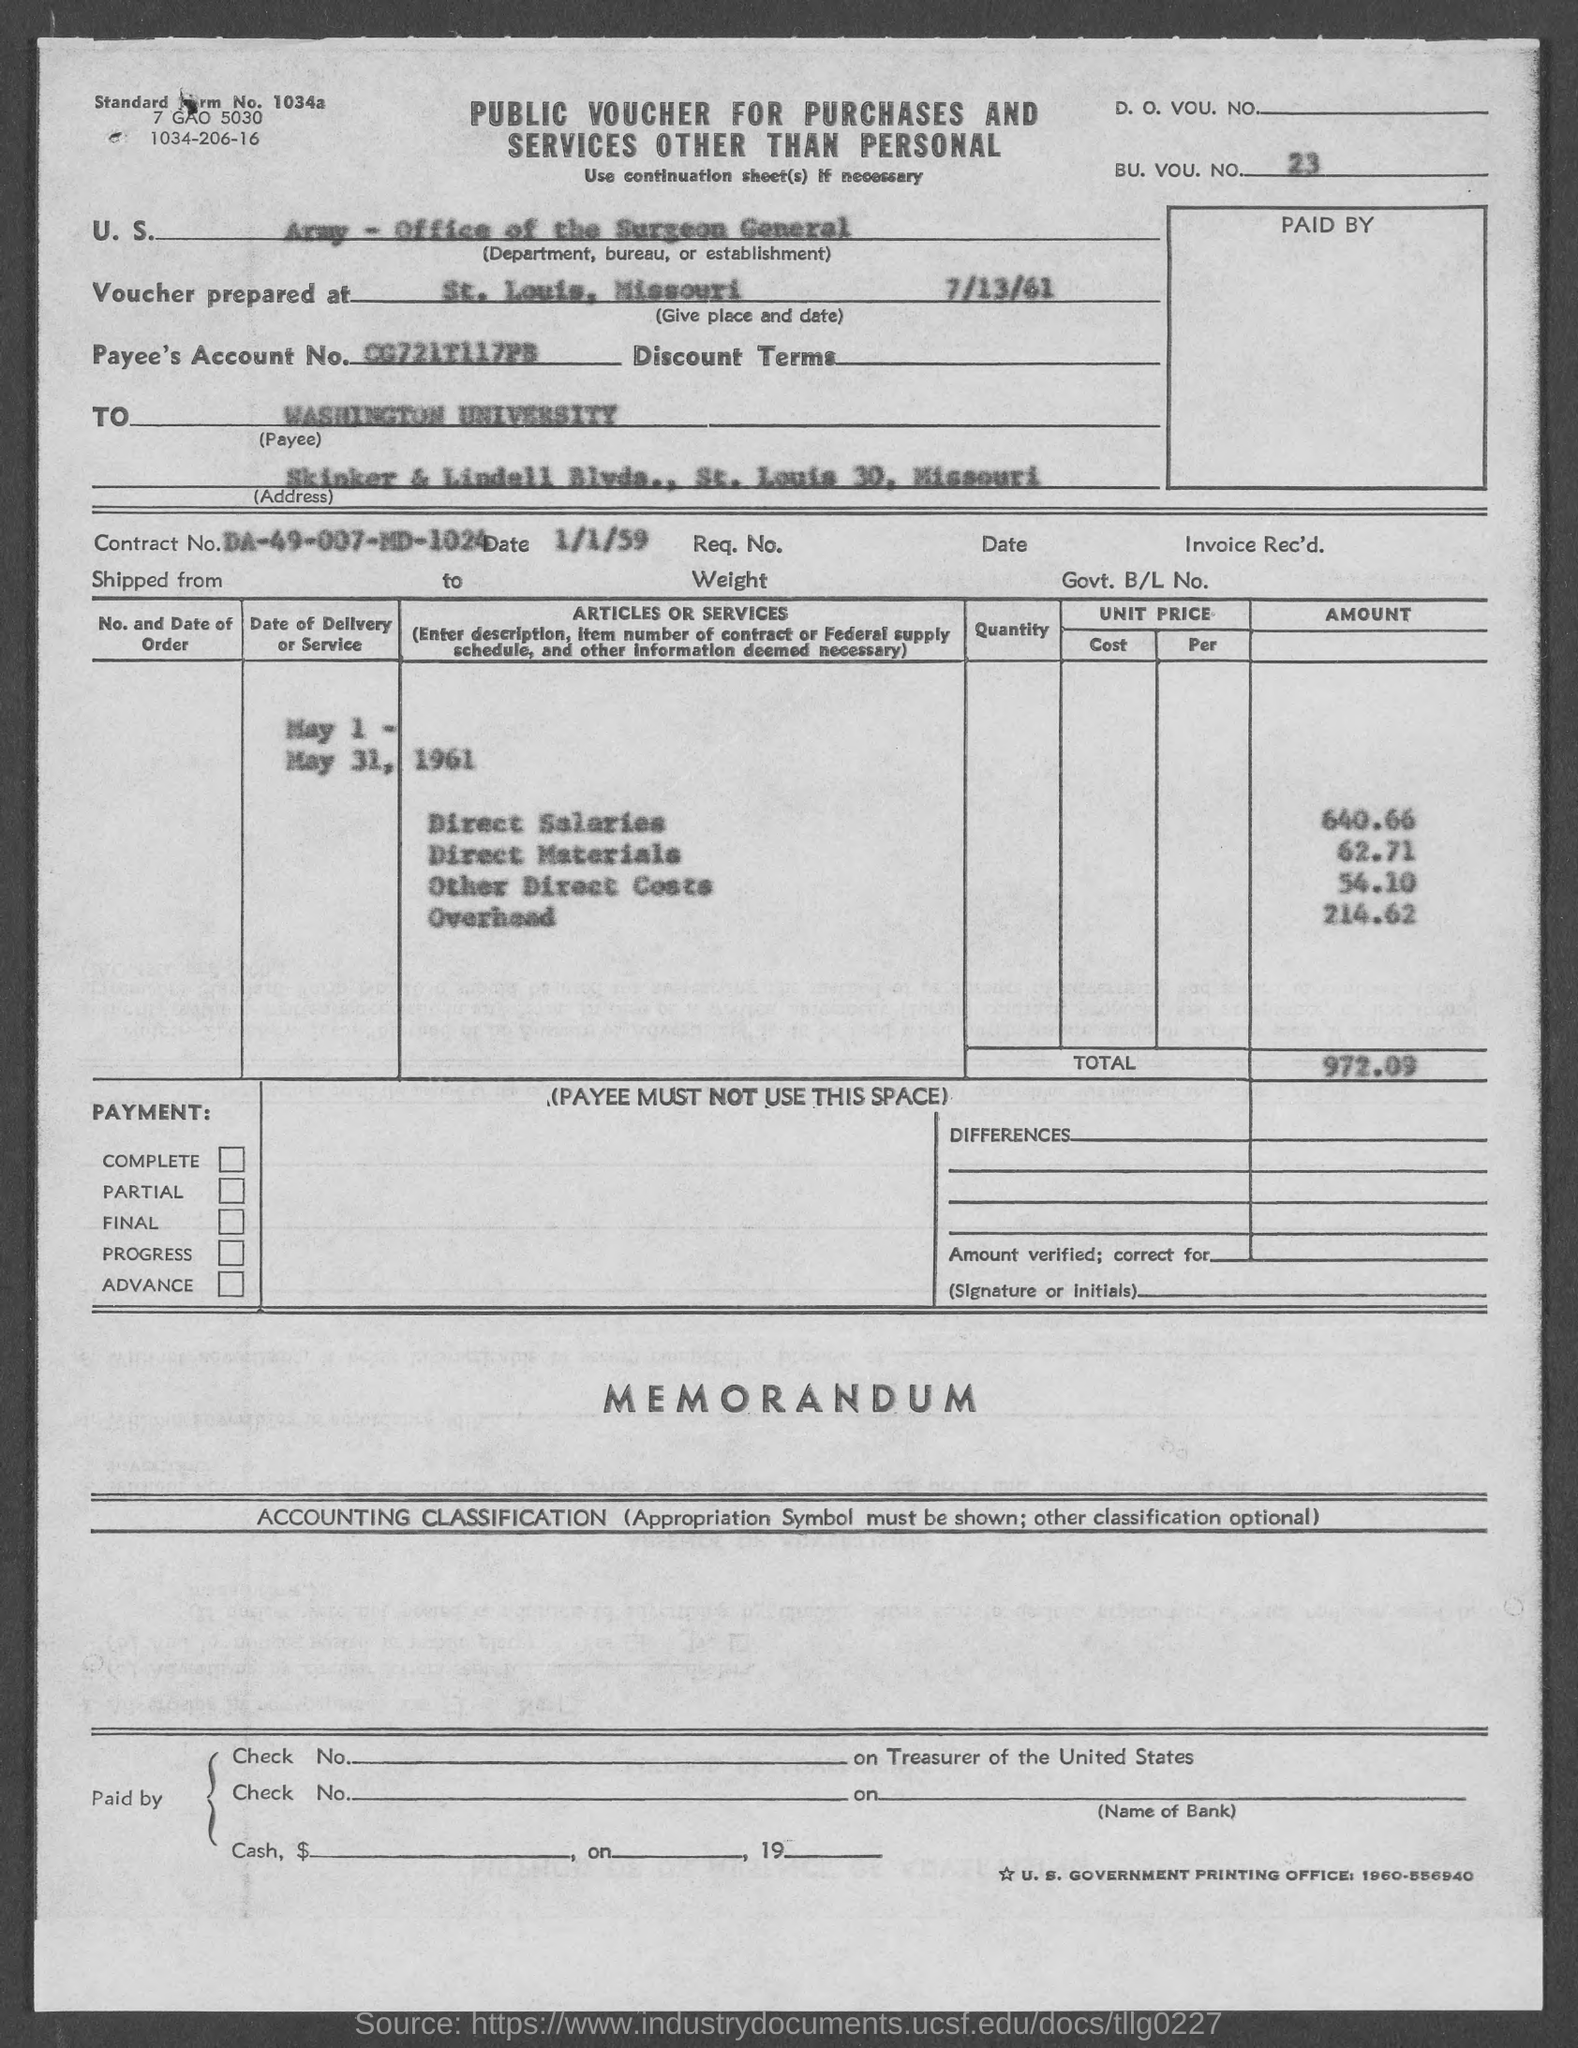What is the bu. voc. no. mentioned in the given form ?
Give a very brief answer. 23. On which date the voucher was prepared as mentioned in the given form ?
Ensure brevity in your answer.  7/13/61. What is the contract no. mentioned in the given form ?
Keep it short and to the point. DA-49-007-MD-1024. What is the amount for direct salaries as mentioned in the given form ?
Ensure brevity in your answer.  640.66. What is the amount for direct materials as mentioned in the given form ?
Your answer should be very brief. 62.71. What is the total amount mentioned in the given form ?
Your answer should be very brief. 972.09. 